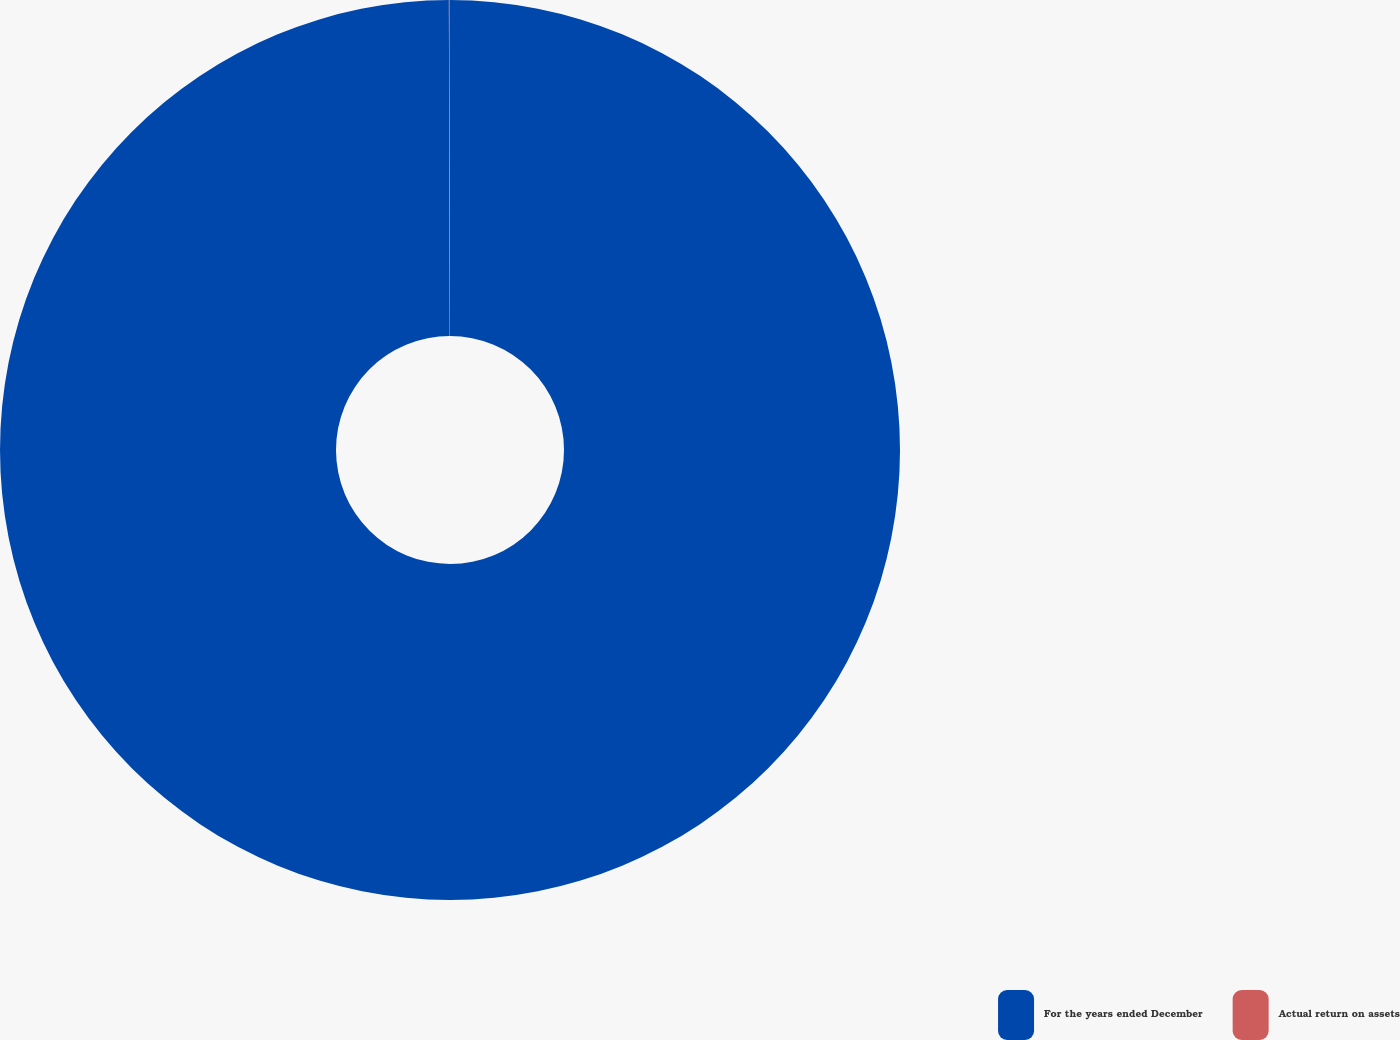Convert chart to OTSL. <chart><loc_0><loc_0><loc_500><loc_500><pie_chart><fcel>For the years ended December<fcel>Actual return on assets<nl><fcel>99.96%<fcel>0.04%<nl></chart> 